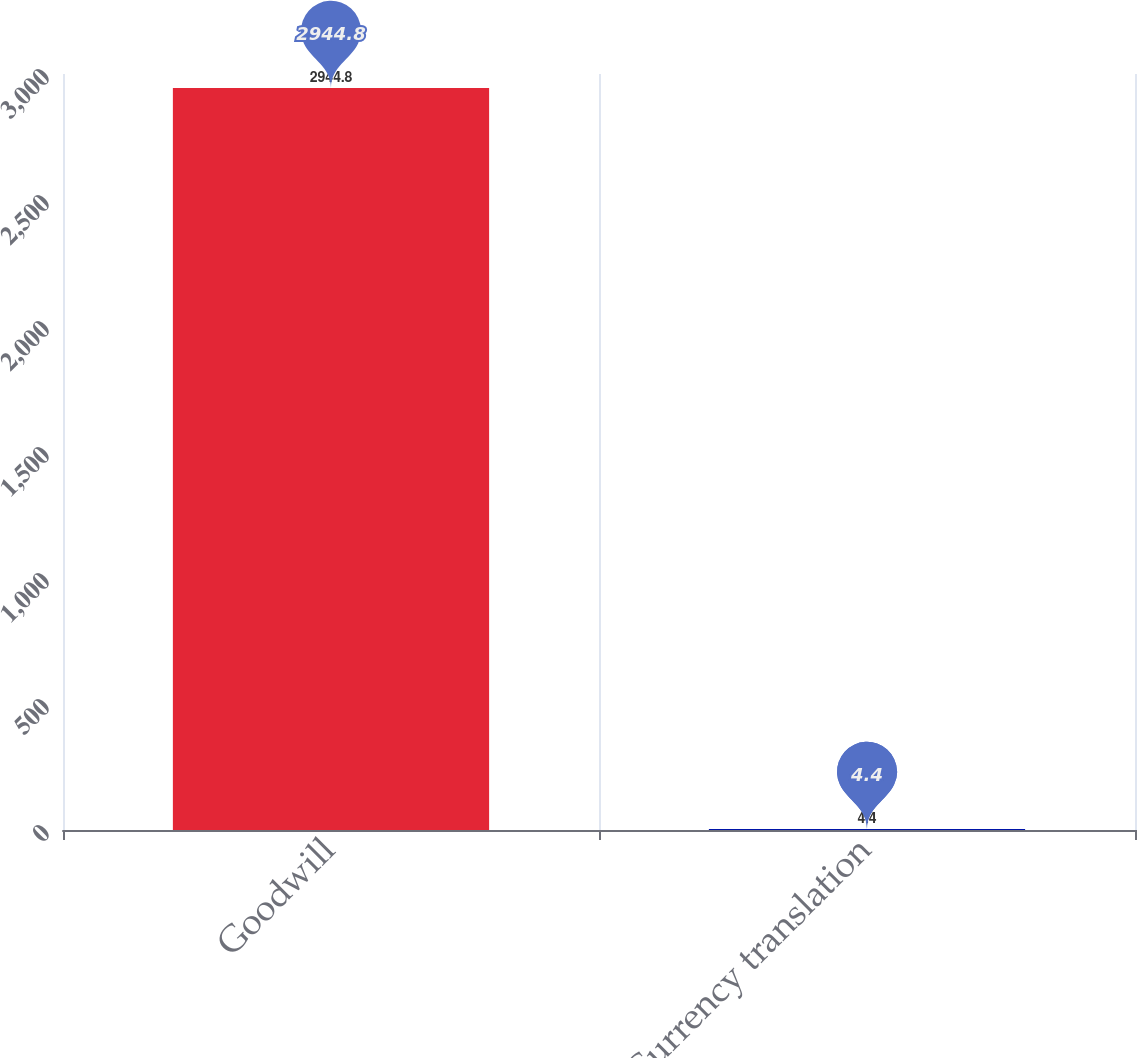<chart> <loc_0><loc_0><loc_500><loc_500><bar_chart><fcel>Goodwill<fcel>Currency translation<nl><fcel>2944.8<fcel>4.4<nl></chart> 